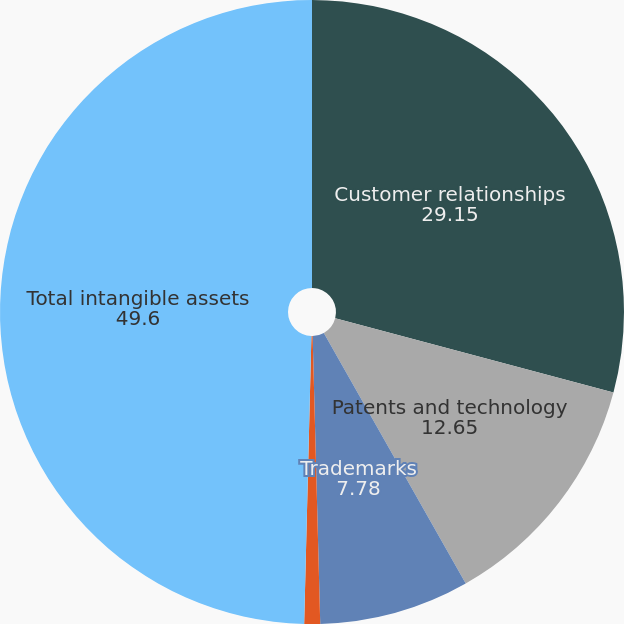Convert chart to OTSL. <chart><loc_0><loc_0><loc_500><loc_500><pie_chart><fcel>Customer relationships<fcel>Patents and technology<fcel>Trademarks<fcel>Other<fcel>Total intangible assets<nl><fcel>29.15%<fcel>12.65%<fcel>7.78%<fcel>0.82%<fcel>49.6%<nl></chart> 